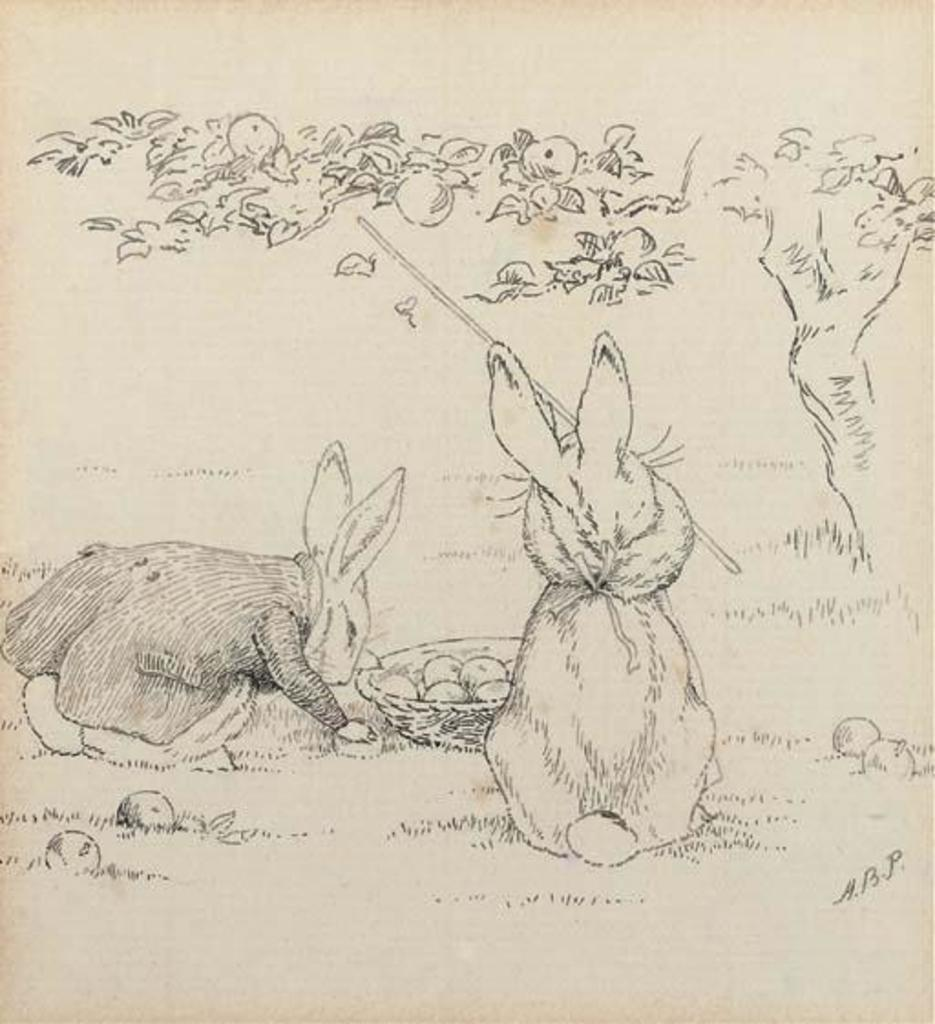What type of art is featured in the image? The image contains pencil art. What animals are depicted in the pencil art? The pencil art depicts rabbits. What is the setting of the scene with the rabbits? The rabbits are standing under a fruit tree, and the scene takes place on grassland. What type of advice is the rabbit giving to the powder in the image? There is no powder or advice-giving rabbit present in the image; it features pencil art of rabbits standing under a fruit tree on grassland. 